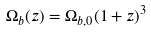<formula> <loc_0><loc_0><loc_500><loc_500>\Omega _ { b } ( z ) = \Omega _ { b , 0 } ( 1 + z ) ^ { 3 }</formula> 